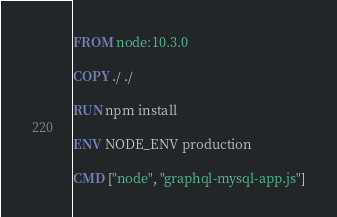<code> <loc_0><loc_0><loc_500><loc_500><_Dockerfile_>FROM node:10.3.0

COPY ./ ./

RUN npm install

ENV NODE_ENV production

CMD ["node", "graphql-mysql-app.js"]</code> 